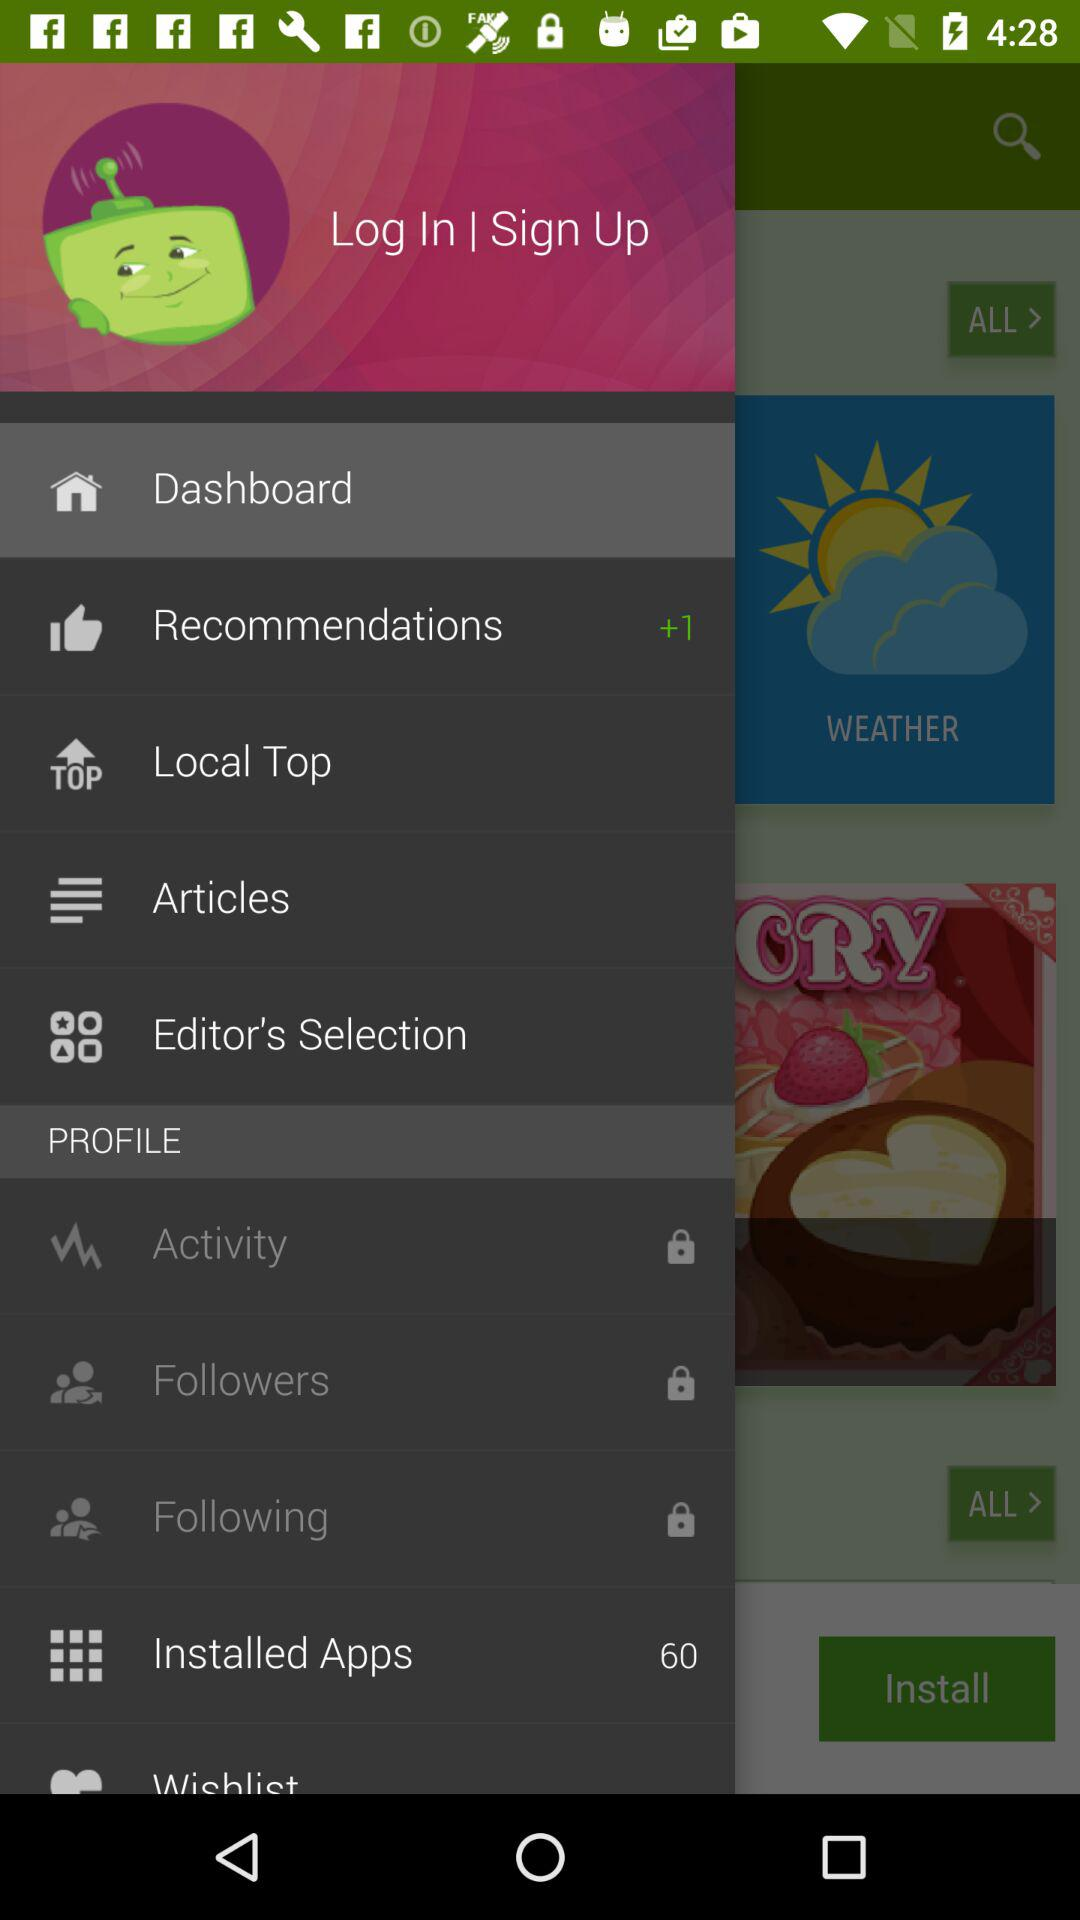How many recommendations are there? There are more than 1 recommendations. 